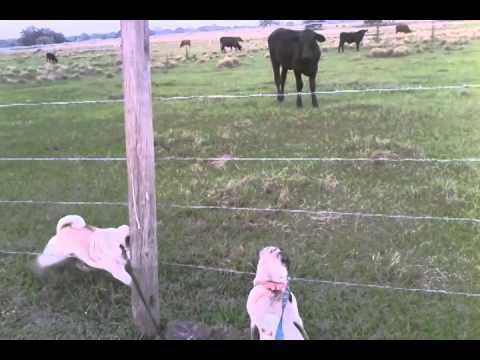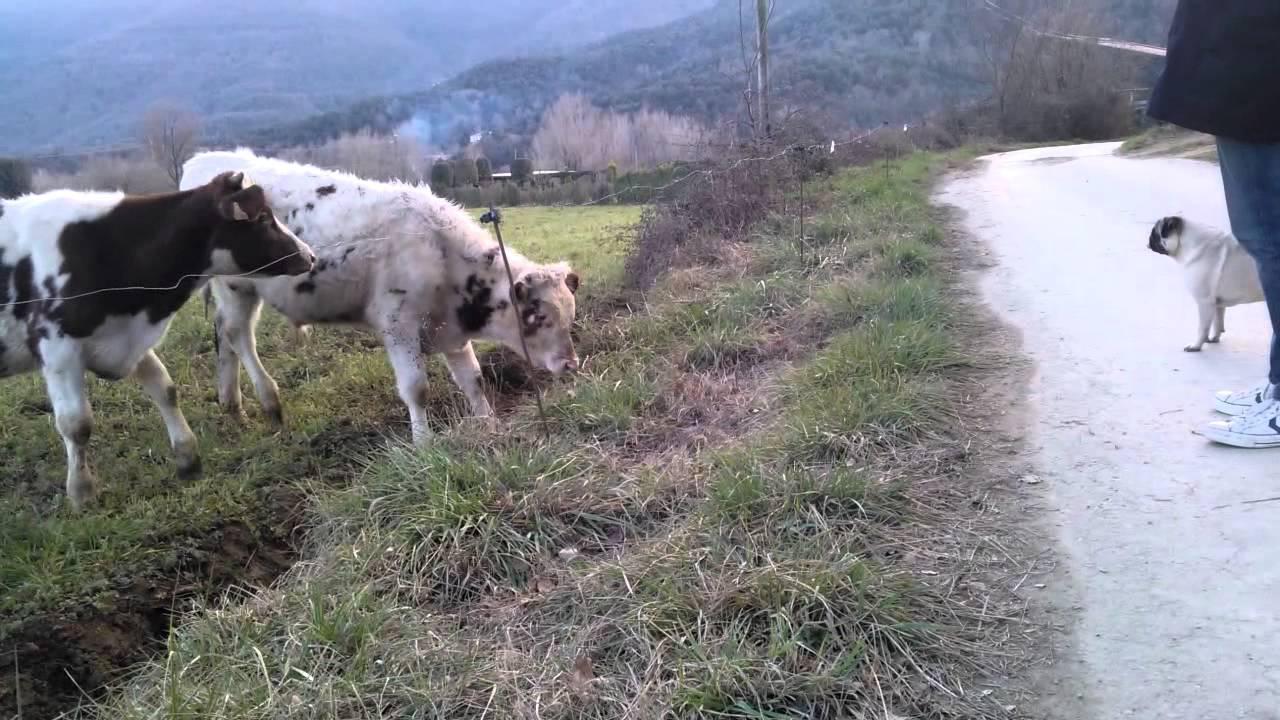The first image is the image on the left, the second image is the image on the right. Assess this claim about the two images: "All of the animals are enclosed in the field.". Correct or not? Answer yes or no. Yes. The first image is the image on the left, the second image is the image on the right. Assess this claim about the two images: "Images show a total of two pugs dressed in black and white cow costumes.". Correct or not? Answer yes or no. No. 